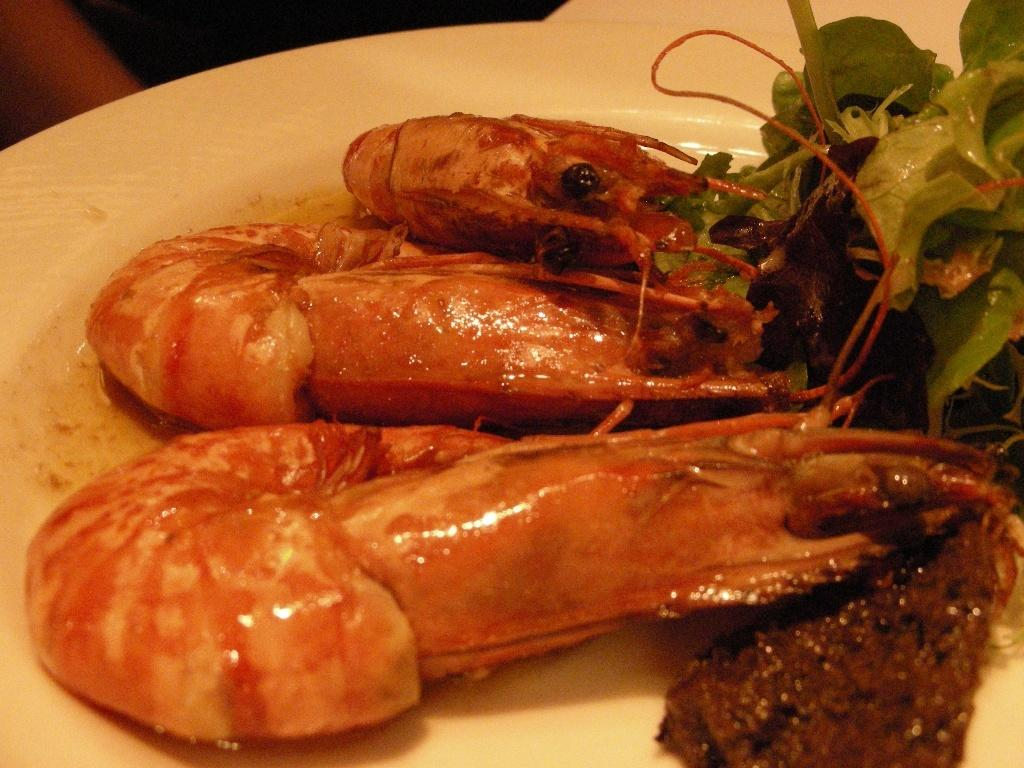What type of food can be seen in the image? The food in the image contains prawns and leafy vegetables. How is the food arranged or presented in the image? The food is in a plate. What type of care is the woman providing for the clouds in the image? There is no woman or clouds present in the image; it only features food in a plate. 